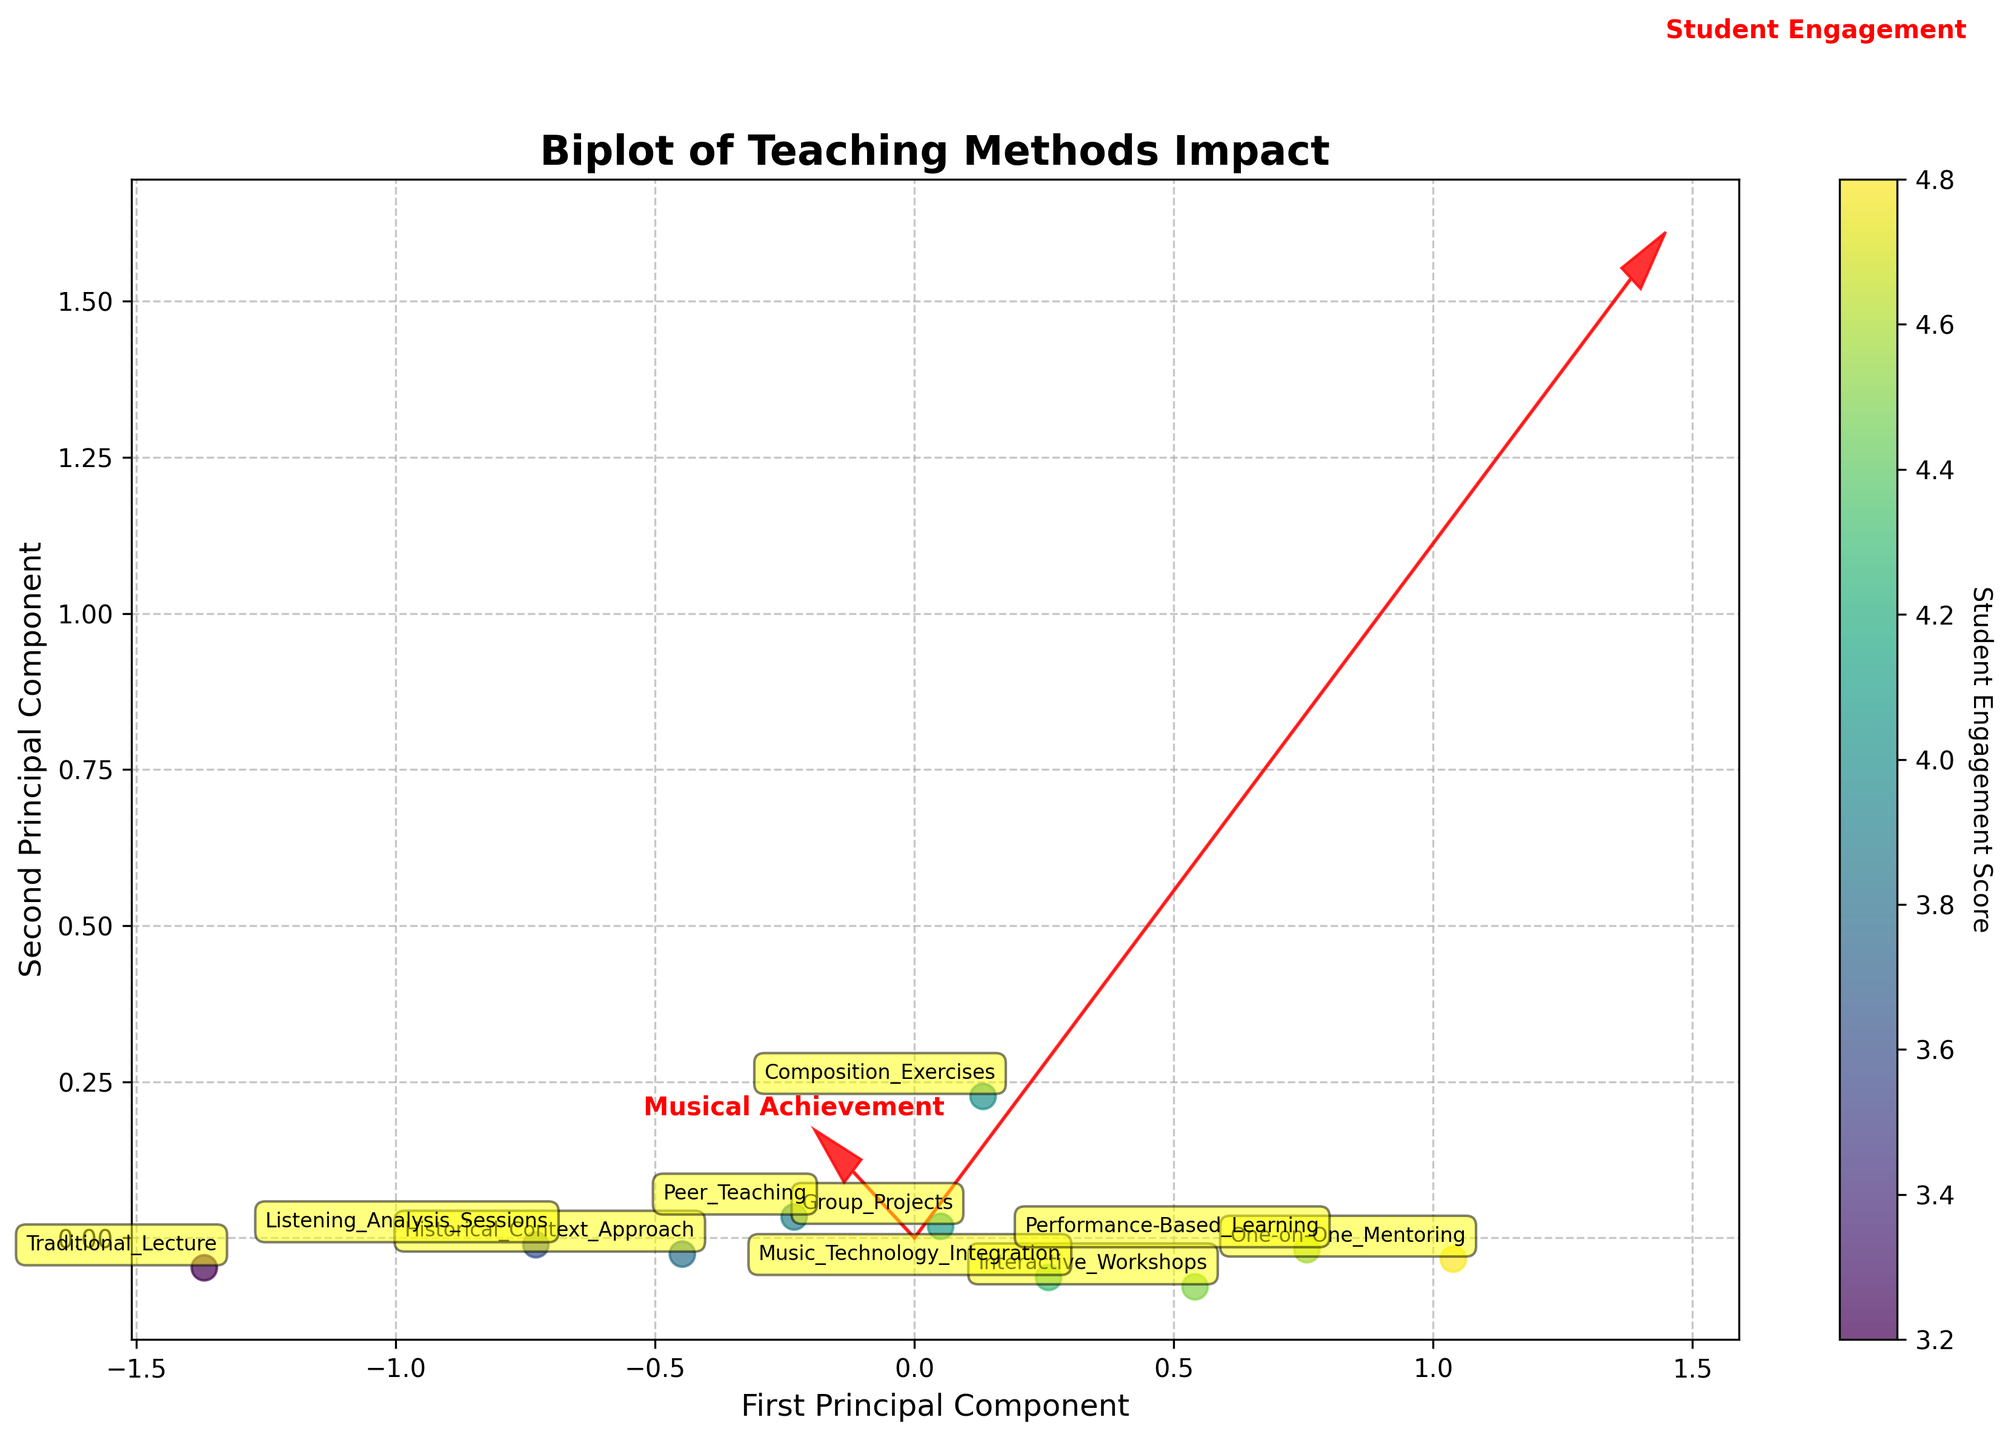What is the title of the biplot? The title of a plot usually appears at the top, and it summarizes the main idea of the graph. In this case, the title is clearly displayed as "Biplot of Teaching Methods Impact".
Answer: Biplot of Teaching Methods Impact How many teaching methods were analyzed in the biplot? By counting the annotated labels visible on the plot, we can determine the number of teaching methods represented. Each label corresponds to a different method.
Answer: 10 Which teaching method has the highest Student Engagement score? By looking at the color gradient and the annotated points, we can see that "One-on-One Mentoring" is positioned in the region associated with the highest Student Engagement.
Answer: One-on-One Mentoring What is the relationship between Student Engagement and Musical Achievement as shown in the biplot? The arrows (principal component vectors) indicate the direction and correlation between the variables. Both arrows point in similar directions, suggesting a positive correlation between Student Engagement and Musical Achievement.
Answer: Positive correlation How is the Performance-Based Learning method positioned relative to the principal components in the biplot? Performance-Based Learning is labeled on the plot. It is located in the upper right quadrant, indicating it has high values for both principal components (aligned with higher Student Engagement and Musical Achievement).
Answer: Upper right quadrant Which two methods are closest to each other in the biplot, and what does this signify? "Group Projects" and "Peer Teaching" are closest to each other in the plot. This close proximity suggests that they have similar impacts on Student Engagement and Musical Achievement.
Answer: Group Projects and Peer Teaching What can you infer about the Historical Context Approach in terms of its impact on engagement and achievement? The Historical Context Approach is positioned lower on the biplot compared to other methods, indicating relatively lower scores in both Student Engagement and Musical Achievement.
Answer: Relatively lower impact Which method is more effective in increasing Musical Achievement: Composition Exercises or Listening Analysis Sessions? By comparing the positions of the two methods on the biplot, Composition Exercises are further to the right along the Musical Achievement axis, indicating it has a higher score.
Answer: Composition Exercises How do the vectors (principal components) influence the interpretation of the teaching methods’ impact? The vectors show the direction and importance of each principal component. The more a method's position aligns with a vector, the more that component contributes to its score. For example, a method aligned with the Student Engagement vector has high engagement.
Answer: They show direction and importance Which methods are found in the lower left quadrant, and what could this indicate about their overall effectiveness? The lower left quadrant contains methods like Traditional Lecture and Historical Context Approach, suggesting these methods have relatively lower Student Engagement and Musical Achievement scores compared to others.
Answer: Traditional Lecture and Historical Context Approach 